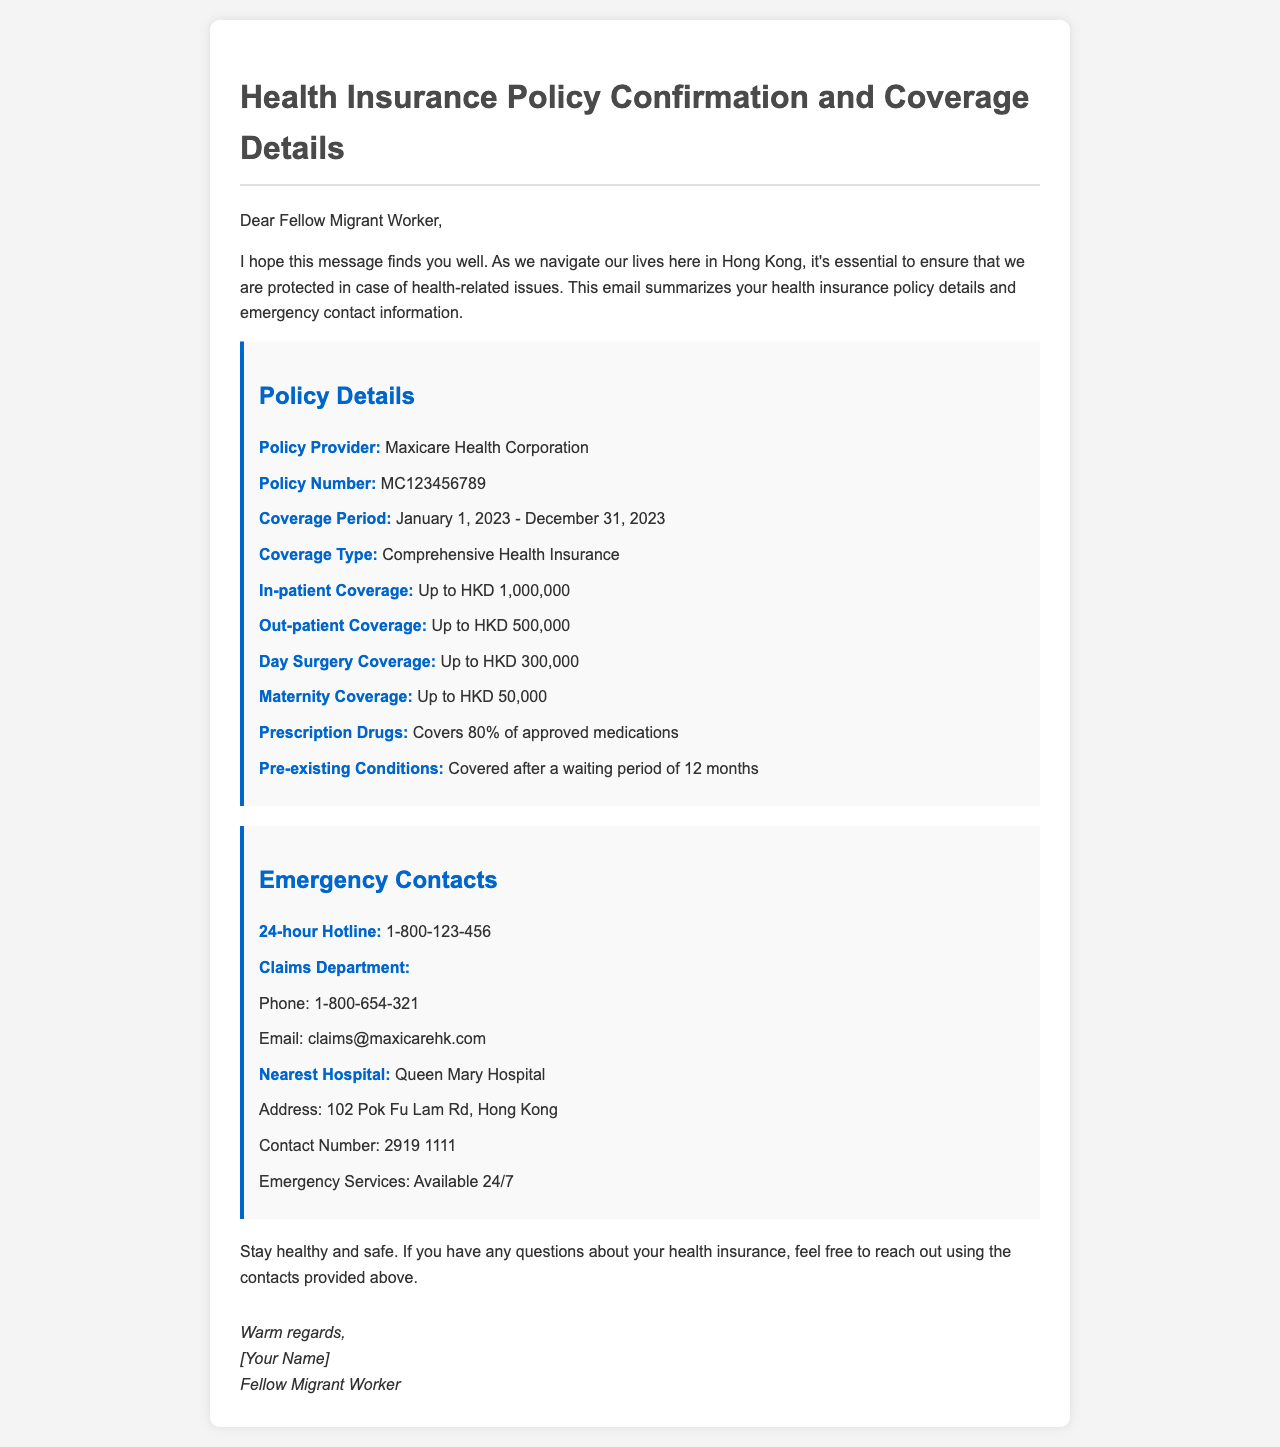What is the policy provider? The policy provider is explicitly mentioned in the policy details section of the document.
Answer: Maxicare Health Corporation What is the policy number? The policy number is stated clearly and can be retrieved from the policy details section.
Answer: MC123456789 What is the coverage period? The coverage period is outlined in the document, providing specific start and end dates.
Answer: January 1, 2023 - December 31, 2023 What is the in-patient coverage limit? The limit for in-patient coverage is specifically indicated in the policy details.
Answer: Up to HKD 1,000,000 How much does the maternity coverage provide? The amount for maternity coverage is specified in the document, giving a clear figure.
Answer: Up to HKD 50,000 What is covered after a waiting period of 12 months? This information is mentioned regarding the conditions covered within the policy.
Answer: Pre-existing Conditions What is the contact number for the Claims Department? The document specifies the contact number for the Claims Department, which is needed when making claims.
Answer: 1-800-654-321 What is the address of the nearest hospital? The nearest hospital's address is explicitly provided in the emergency contacts section.
Answer: 102 Pok Fu Lam Rd, Hong Kong What type of health insurance is provided? The type of coverage is mentioned in the document, indicating the comprehensive nature of the insurance.
Answer: Comprehensive Health Insurance 